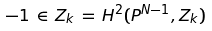Convert formula to latex. <formula><loc_0><loc_0><loc_500><loc_500>- 1 \, \in \, { Z } _ { k } \, = \, H ^ { 2 } ( { P } ^ { N - 1 } , { Z } _ { k } )</formula> 